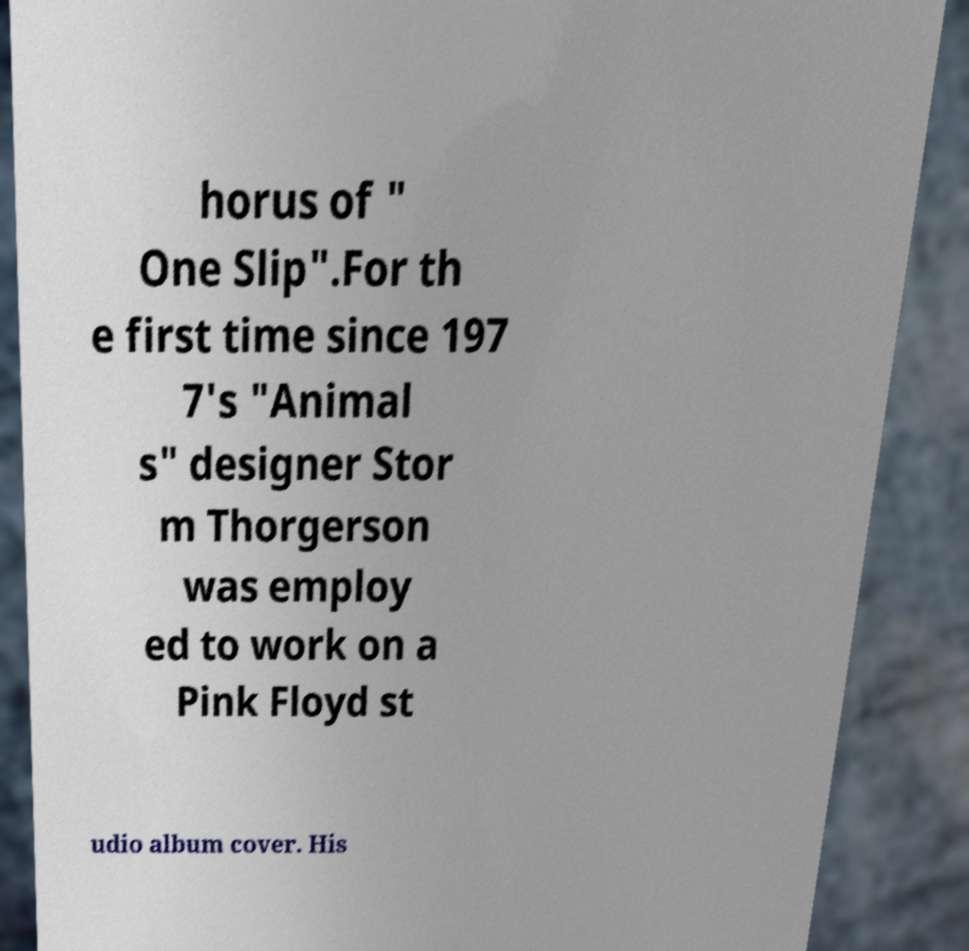Could you extract and type out the text from this image? horus of " One Slip".For th e first time since 197 7's "Animal s" designer Stor m Thorgerson was employ ed to work on a Pink Floyd st udio album cover. His 